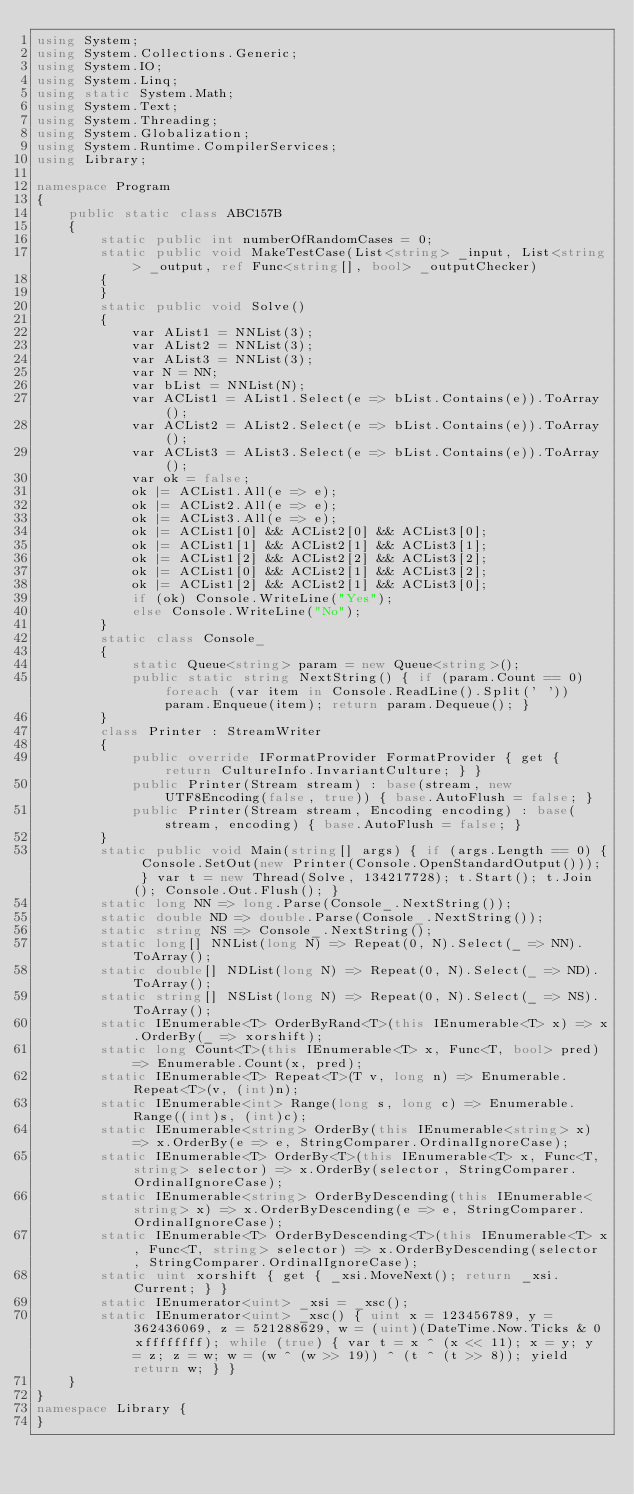<code> <loc_0><loc_0><loc_500><loc_500><_C#_>using System;
using System.Collections.Generic;
using System.IO;
using System.Linq;
using static System.Math;
using System.Text;
using System.Threading;
using System.Globalization;
using System.Runtime.CompilerServices;
using Library;

namespace Program
{
    public static class ABC157B
    {
        static public int numberOfRandomCases = 0;
        static public void MakeTestCase(List<string> _input, List<string> _output, ref Func<string[], bool> _outputChecker)
        {
        }
        static public void Solve()
        {
            var AList1 = NNList(3);
            var AList2 = NNList(3);
            var AList3 = NNList(3);
            var N = NN;
            var bList = NNList(N);
            var ACList1 = AList1.Select(e => bList.Contains(e)).ToArray();
            var ACList2 = AList2.Select(e => bList.Contains(e)).ToArray();
            var ACList3 = AList3.Select(e => bList.Contains(e)).ToArray();
            var ok = false;
            ok |= ACList1.All(e => e);
            ok |= ACList2.All(e => e);
            ok |= ACList3.All(e => e);
            ok |= ACList1[0] && ACList2[0] && ACList3[0];
            ok |= ACList1[1] && ACList2[1] && ACList3[1];
            ok |= ACList1[2] && ACList2[2] && ACList3[2];
            ok |= ACList1[0] && ACList2[1] && ACList3[2];
            ok |= ACList1[2] && ACList2[1] && ACList3[0];
            if (ok) Console.WriteLine("Yes");
            else Console.WriteLine("No");
        }
        static class Console_
        {
            static Queue<string> param = new Queue<string>();
            public static string NextString() { if (param.Count == 0) foreach (var item in Console.ReadLine().Split(' ')) param.Enqueue(item); return param.Dequeue(); }
        }
        class Printer : StreamWriter
        {
            public override IFormatProvider FormatProvider { get { return CultureInfo.InvariantCulture; } }
            public Printer(Stream stream) : base(stream, new UTF8Encoding(false, true)) { base.AutoFlush = false; }
            public Printer(Stream stream, Encoding encoding) : base(stream, encoding) { base.AutoFlush = false; }
        }
        static public void Main(string[] args) { if (args.Length == 0) { Console.SetOut(new Printer(Console.OpenStandardOutput())); } var t = new Thread(Solve, 134217728); t.Start(); t.Join(); Console.Out.Flush(); }
        static long NN => long.Parse(Console_.NextString());
        static double ND => double.Parse(Console_.NextString());
        static string NS => Console_.NextString();
        static long[] NNList(long N) => Repeat(0, N).Select(_ => NN).ToArray();
        static double[] NDList(long N) => Repeat(0, N).Select(_ => ND).ToArray();
        static string[] NSList(long N) => Repeat(0, N).Select(_ => NS).ToArray();
        static IEnumerable<T> OrderByRand<T>(this IEnumerable<T> x) => x.OrderBy(_ => xorshift);
        static long Count<T>(this IEnumerable<T> x, Func<T, bool> pred) => Enumerable.Count(x, pred);
        static IEnumerable<T> Repeat<T>(T v, long n) => Enumerable.Repeat<T>(v, (int)n);
        static IEnumerable<int> Range(long s, long c) => Enumerable.Range((int)s, (int)c);
        static IEnumerable<string> OrderBy(this IEnumerable<string> x) => x.OrderBy(e => e, StringComparer.OrdinalIgnoreCase);
        static IEnumerable<T> OrderBy<T>(this IEnumerable<T> x, Func<T, string> selector) => x.OrderBy(selector, StringComparer.OrdinalIgnoreCase);
        static IEnumerable<string> OrderByDescending(this IEnumerable<string> x) => x.OrderByDescending(e => e, StringComparer.OrdinalIgnoreCase);
        static IEnumerable<T> OrderByDescending<T>(this IEnumerable<T> x, Func<T, string> selector) => x.OrderByDescending(selector, StringComparer.OrdinalIgnoreCase);
        static uint xorshift { get { _xsi.MoveNext(); return _xsi.Current; } }
        static IEnumerator<uint> _xsi = _xsc();
        static IEnumerator<uint> _xsc() { uint x = 123456789, y = 362436069, z = 521288629, w = (uint)(DateTime.Now.Ticks & 0xffffffff); while (true) { var t = x ^ (x << 11); x = y; y = z; z = w; w = (w ^ (w >> 19)) ^ (t ^ (t >> 8)); yield return w; } }
    }
}
namespace Library {
}
</code> 